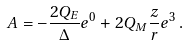Convert formula to latex. <formula><loc_0><loc_0><loc_500><loc_500>A = - \frac { 2 Q _ { E } } { \Delta } e ^ { 0 } + 2 Q _ { M } \frac { z } { r } e ^ { 3 } \, .</formula> 